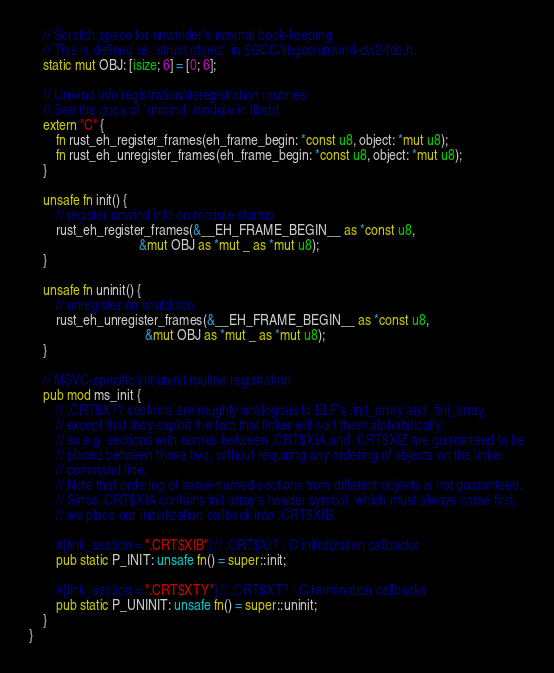<code> <loc_0><loc_0><loc_500><loc_500><_Rust_>
    // Scratch space for unwinder's internal book-keeping.
    // This is defined as `struct object` in $GCC/libgcc/unwind-dw2-fde.h.
    static mut OBJ: [isize; 6] = [0; 6];

    // Unwind info registration/deregistration routines.
    // See the docs of `unwind` module in libstd.
    extern "C" {
        fn rust_eh_register_frames(eh_frame_begin: *const u8, object: *mut u8);
        fn rust_eh_unregister_frames(eh_frame_begin: *const u8, object: *mut u8);
    }

    unsafe fn init() {
        // register unwind info on module startup
        rust_eh_register_frames(&__EH_FRAME_BEGIN__ as *const u8,
                                &mut OBJ as *mut _ as *mut u8);
    }

    unsafe fn uninit() {
        // unregister on shutdown
        rust_eh_unregister_frames(&__EH_FRAME_BEGIN__ as *const u8,
                                  &mut OBJ as *mut _ as *mut u8);
    }

    // MSVC-specific init/uninit routine registration
    pub mod ms_init {
        // .CRT$X?? sections are roughly analogous to ELF's .init_array and .fini_array,
        // except that they exploit the fact that linker will sort them alphabitically,
        // so e.g. sections with names between .CRT$XIA and .CRT$XIZ are guaranteed to be
        // placed between those two, without requiring any ordering of objects on the linker
        // command line.
        // Note that ordering of same-named sections from different objects is not guaranteed.
        // Since .CRT$XIA contains init array's header symbol, which must always come first,
        // we place our initialization callback into .CRT$XIB.

        #[link_section = ".CRT$XIB"] // .CRT$XI? : C initialization callbacks
        pub static P_INIT: unsafe fn() = super::init;

        #[link_section = ".CRT$XTY"] // .CRT$XT? : C termination callbacks
        pub static P_UNINIT: unsafe fn() = super::uninit;
    }
}
</code> 